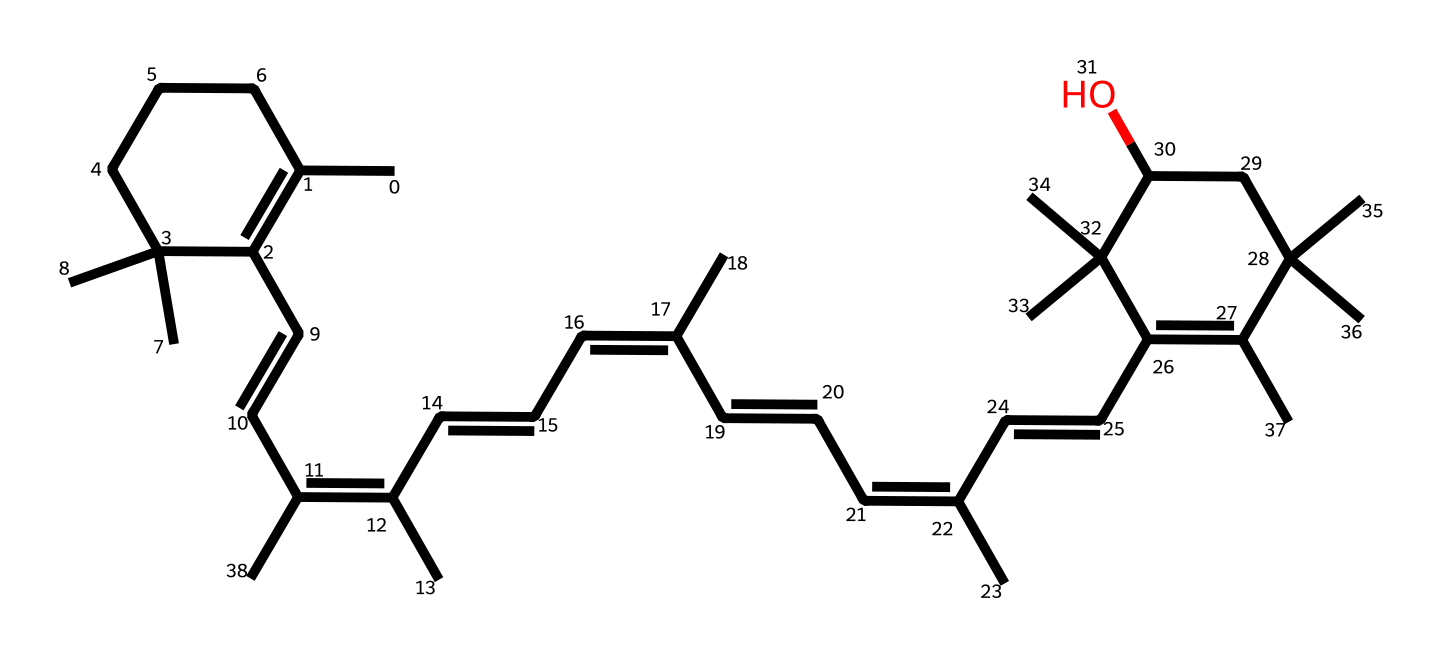What is the molecular formula of astaxanthin? To determine the molecular formula from a SMILES representation, analyze the number of each type of atom. Counting the carbon (C), hydrogen (H), and oxygen (O) atoms gives C40, H52, and O4.
Answer: C40H52O4 How many rings are present in the structure of astaxanthin? By inspecting the structure, you identify the presence of cyclic components. In astaxanthin, there are two identified rings formed in the compound's arrangement.
Answer: 2 What functional groups are present in astaxanthin? Evaluating the chemical structure, look for recognizable groups. Astaxanthin contains hydroxyl (-OH) groups as part of its structure.
Answer: hydroxyl groups How many double bonds are in the astaxanthin molecule? To find the number of double bonds, check for "=" signs in the chemical structure representation. In astaxanthin, there are 11 double bonds identified, contributing to its unsaturated nature.
Answer: 11 What feature of astaxanthin contributes to its antioxidant properties? Analyzing the structure reveals the presence of conjugated double bonds across the molecule which allow for electron delocalization, enhancing its antioxidant activity.
Answer: conjugated double bonds Which type of organisms commonly contain astaxanthin? Astaxanthin is primarily found in marine organisms such as shrimp, salmon, and various algae. Therefore, the answer would relate to these categories of organisms.
Answer: marine organisms 